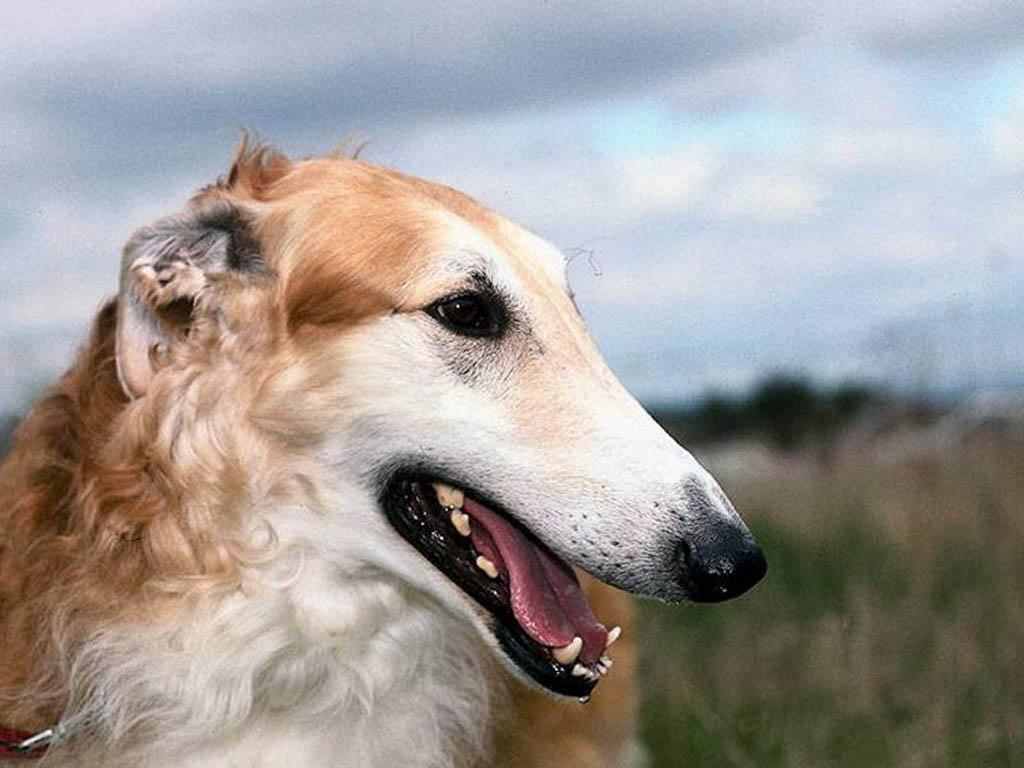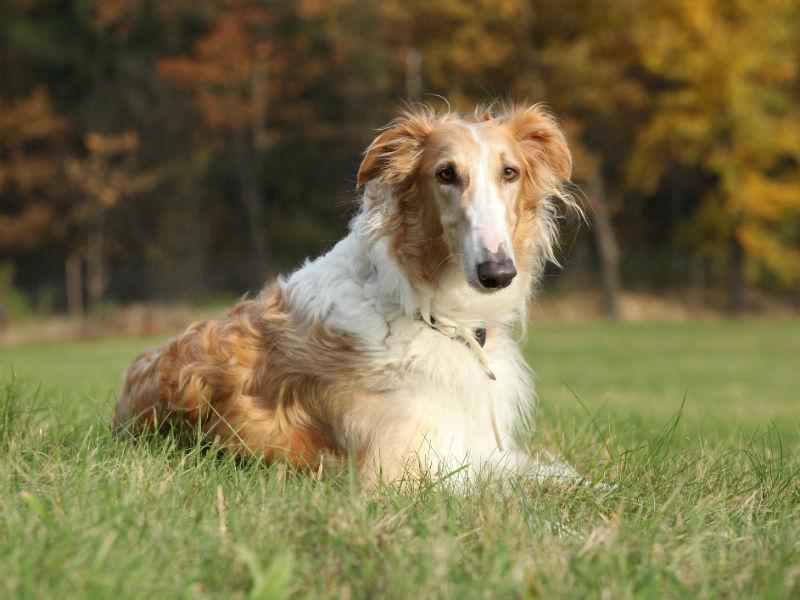The first image is the image on the left, the second image is the image on the right. Analyze the images presented: Is the assertion "The left image is a profile with the dog facing right." valid? Answer yes or no. Yes. 